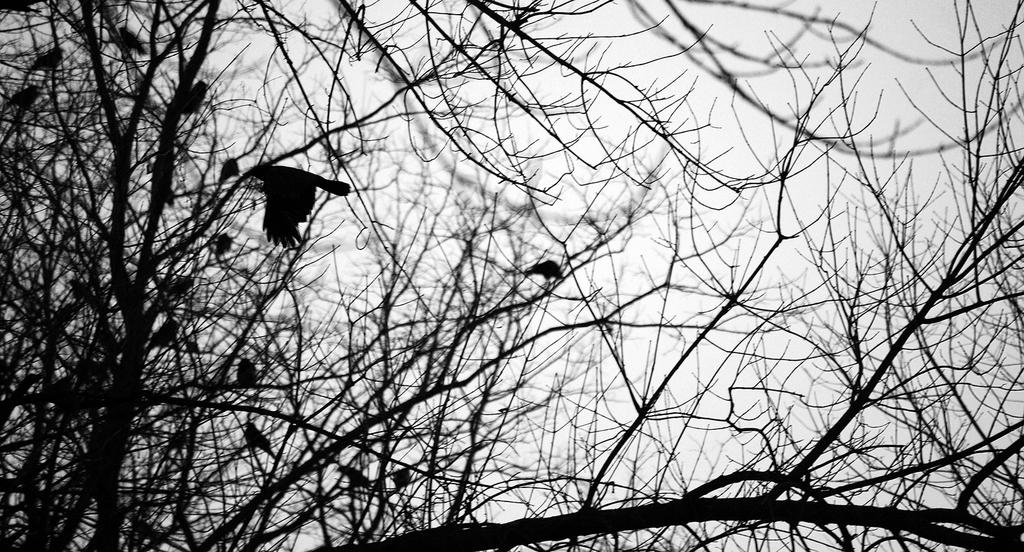What type of animals are on the branches of the tree in the image? There are birds on the branches of the tree in the image. What is the condition of the tree? The tree appears to be dried. What can be seen in the background of the image? There is a sky visible in the background of the image. What type of disease is affecting the birds in the image? There is no indication of any disease affecting the birds in the image. Can you see a chain hanging from the tree in the image? There is no chain visible in the image. 